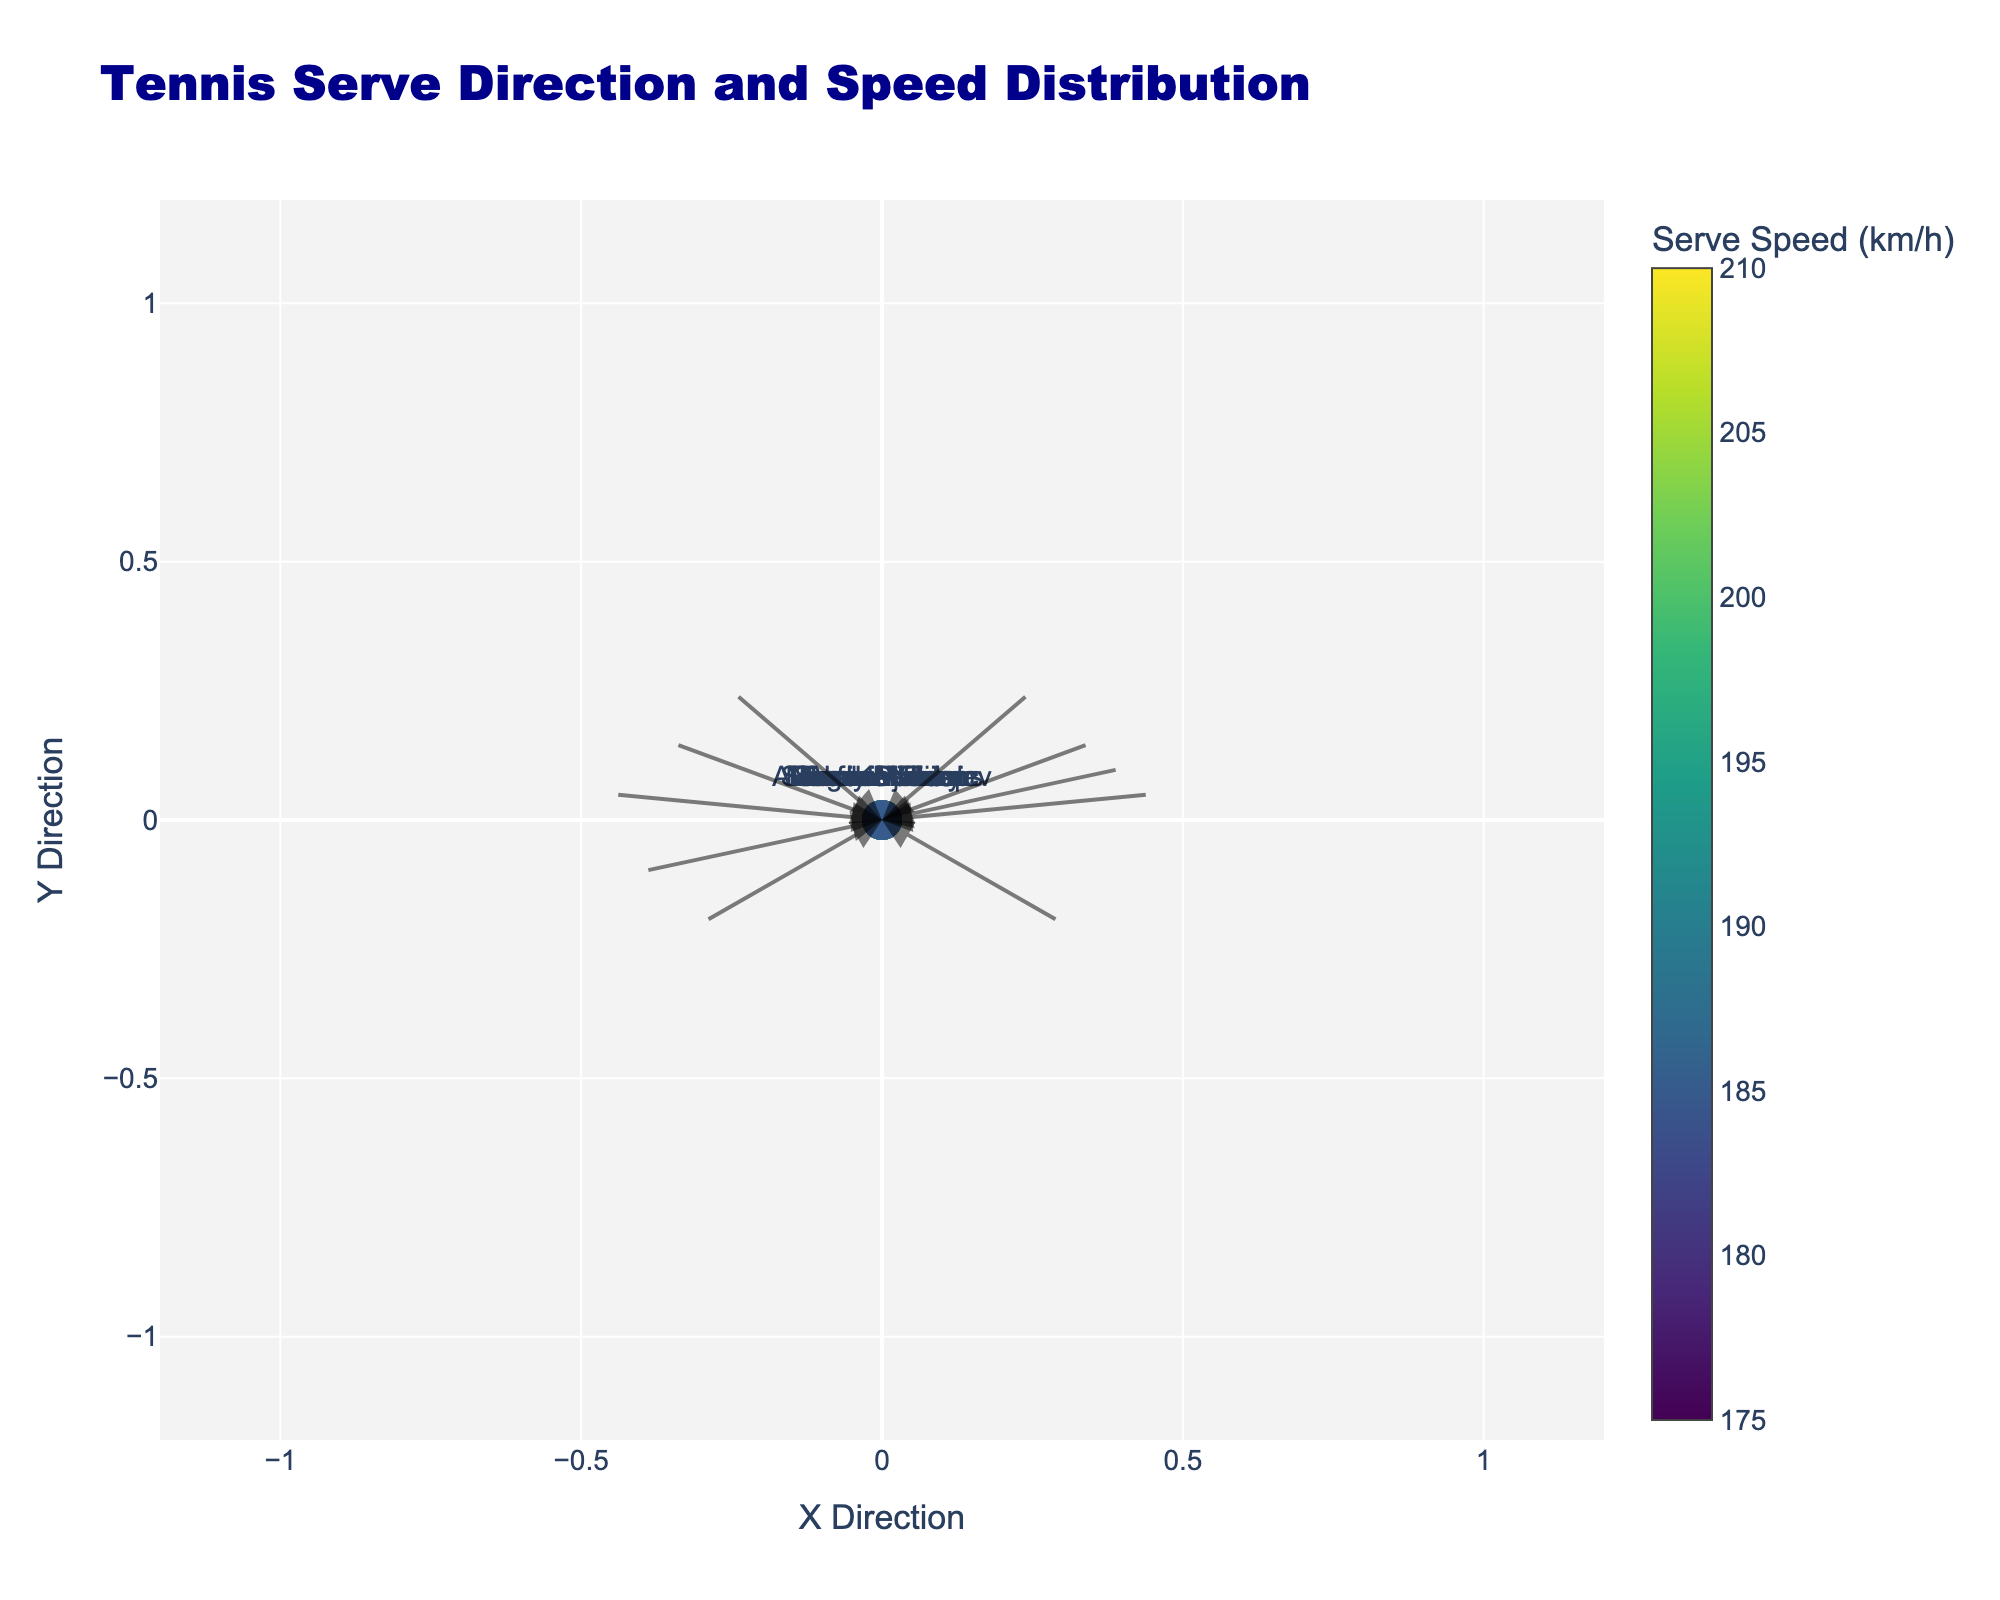What's the title of the quiver plot? The title of the plot is usually found at the top center of the figure. In this case, it clearly states "Tennis Serve Direction and Speed Distribution".
Answer: Tennis Serve Direction and Speed Distribution How many players' serve directions and speeds are displayed in the figure? To count the number of players, you can look at the unique markers in the figure and check the text labels next to each marker. Each marker corresponds to one player.
Answer: 10 What is the serve speed of Novak Djokovic? Novak Djokovic is one of the players labeled in the plot. By looking at the color of his marker and correlating it with the color display or by hovering over his marker, you can find the serve speed.
Answer: 200 km/h Which player has the highest serve speed and what is it? By interpreting the colors and examining the text labels of markers, you'll identify the marker with the highest value on the color scale. In this case, John Isner's marker has the highest serve speed.
Answer: John Isner, 210 km/h Whose serve direction has the longest vector magnitude? To determine this, you will compute the magnitude of the serve vectors using the formula sqrt(u^2 + v^2) for each player and identify the player with the largest magnitude.
Answer: John Isner What is the directional vector of Rafael Nadal's serve? The directional vector is depicted by the arrow that starts at the origin for Rafael Nadal. By reading the arrow, you get the u and v components of his serve direction.
Answer: (-0.7, 0.3) Which players have a serve drawing an arrow to the lower left quadrant? Players whose serves have negative x (u) and negative y (v) components will have arrows directed towards the lower left quadrant.
Answer: Ivo Karlovic, Simona Halep Compare the serve speeds of Roger Federer and Serena Williams. Whose serve is faster? By looking at the markers or text annotations tied to each player and comparing their given serve speeds, you'll find that Federer and Williams have specific values.
Answer: Roger Federer, 185 km/h Calculate the average serve speed of all players. Sum all the serve speeds and divide by the number of players. The serve speeds are 200, 195, 185, 180, 210, 205, 190, 175, 195, 185. The sum is 1940, and the average is 1940/10.
Answer: 194 km/h 